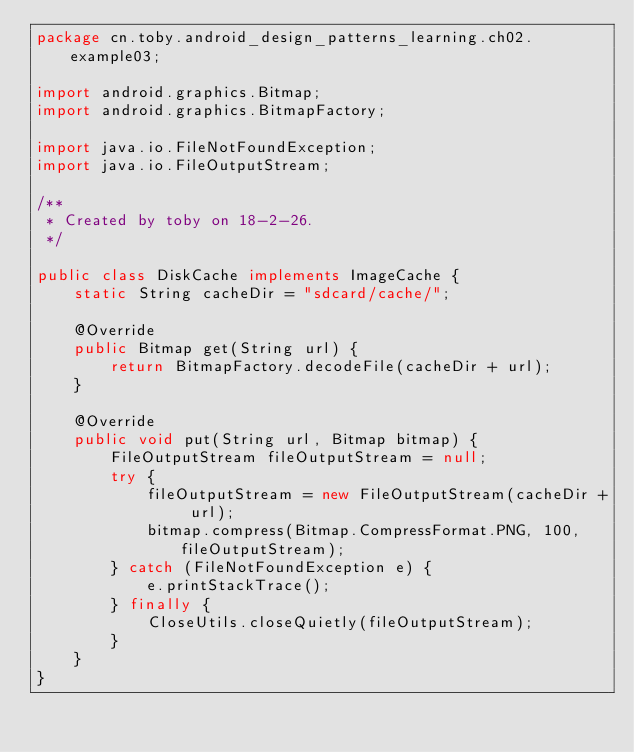Convert code to text. <code><loc_0><loc_0><loc_500><loc_500><_Java_>package cn.toby.android_design_patterns_learning.ch02.example03;

import android.graphics.Bitmap;
import android.graphics.BitmapFactory;

import java.io.FileNotFoundException;
import java.io.FileOutputStream;

/**
 * Created by toby on 18-2-26.
 */

public class DiskCache implements ImageCache {
    static String cacheDir = "sdcard/cache/";

    @Override
    public Bitmap get(String url) {
        return BitmapFactory.decodeFile(cacheDir + url);
    }

    @Override
    public void put(String url, Bitmap bitmap) {
        FileOutputStream fileOutputStream = null;
        try {
            fileOutputStream = new FileOutputStream(cacheDir + url);
            bitmap.compress(Bitmap.CompressFormat.PNG, 100, fileOutputStream);
        } catch (FileNotFoundException e) {
            e.printStackTrace();
        } finally {
            CloseUtils.closeQuietly(fileOutputStream);
        }
    }
}
</code> 